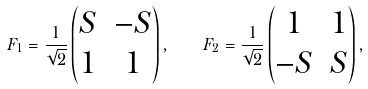Convert formula to latex. <formula><loc_0><loc_0><loc_500><loc_500>F _ { 1 } = \frac { 1 } { \sqrt { 2 } } \begin{pmatrix} S & - S \\ 1 & 1 \end{pmatrix} , \quad F _ { 2 } = \frac { 1 } { \sqrt { 2 } } \begin{pmatrix} 1 & 1 \\ - S & S \end{pmatrix} ,</formula> 